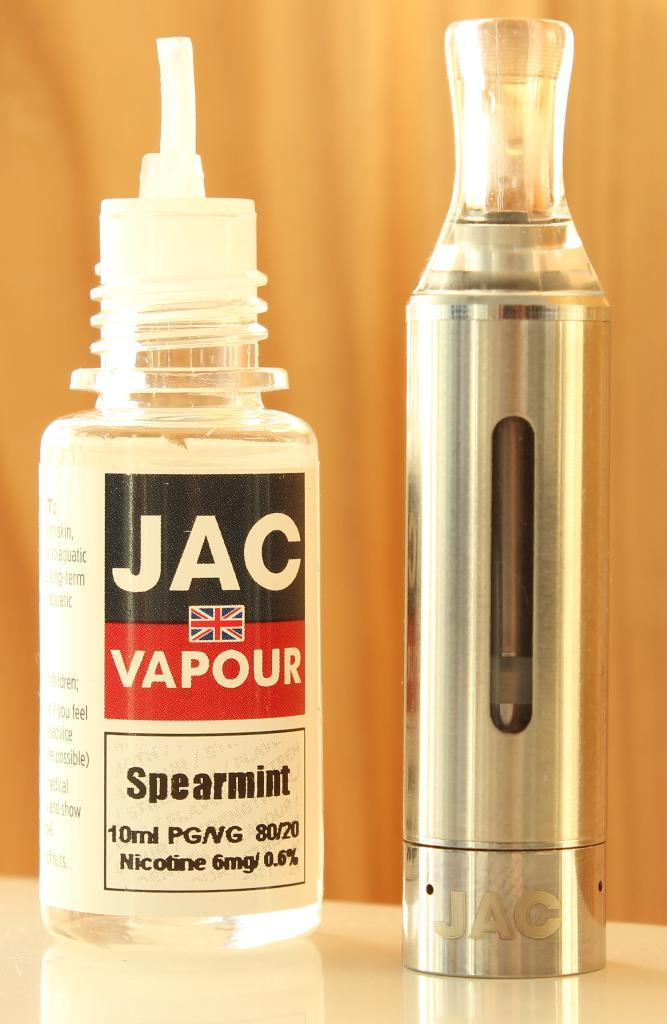<image>
Offer a succinct explanation of the picture presented. Jac Vapour spearmint that contains nicotine inside the bottle 